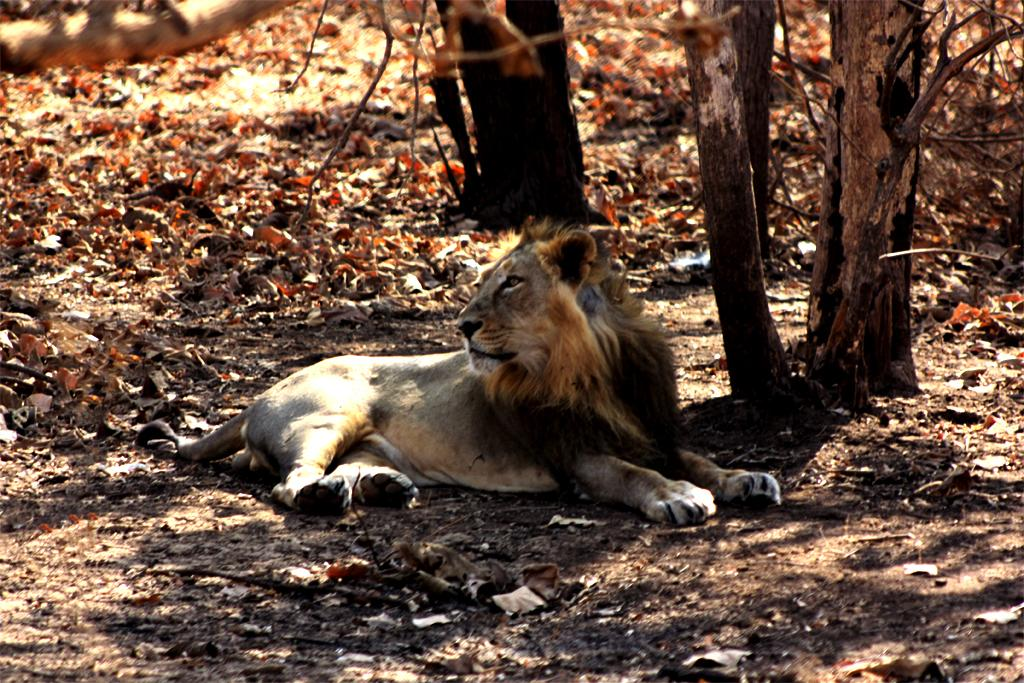What type of animal is in the image? There is a lion in the image. What natural elements can be seen in the image? Tree trunks, branches, and leaves on the ground are visible in the image. How does the lion show respect to the tree in the image? The image does not depict the lion showing respect to the tree, as it is a still image and does not convey emotions or actions. 